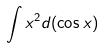<formula> <loc_0><loc_0><loc_500><loc_500>\int x ^ { 2 } d ( \cos x )</formula> 